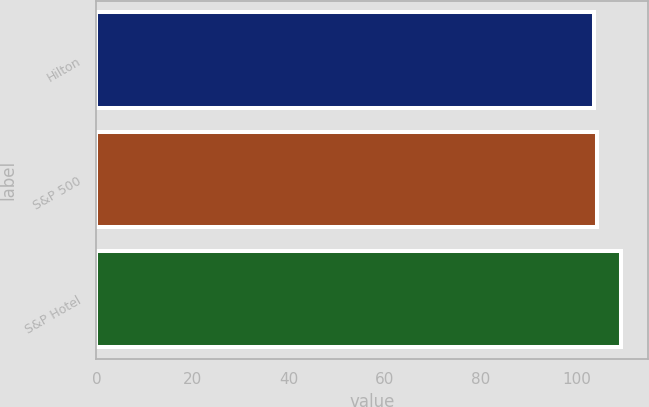<chart> <loc_0><loc_0><loc_500><loc_500><bar_chart><fcel>Hilton<fcel>S&P 500<fcel>S&P Hotel<nl><fcel>103.49<fcel>104.1<fcel>109.17<nl></chart> 